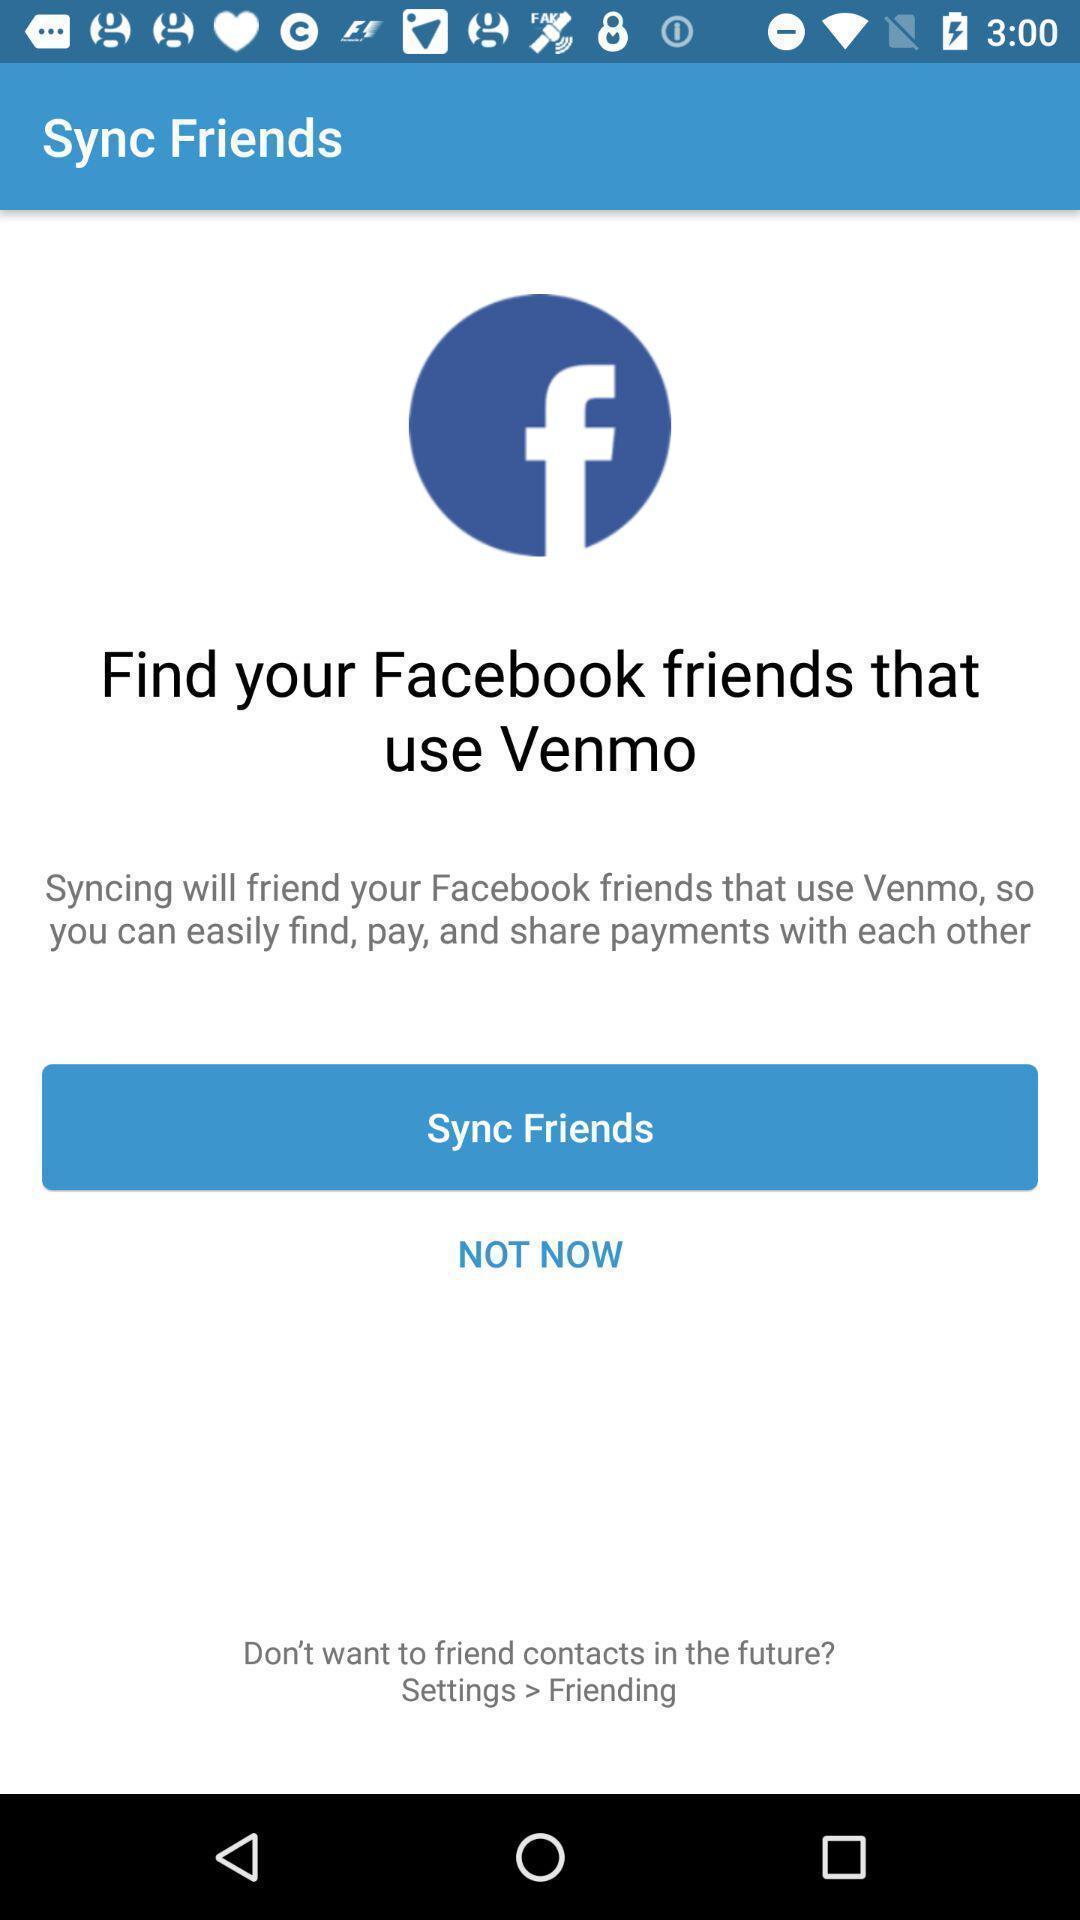Explain what's happening in this screen capture. Page for syncing friends of a social app. 